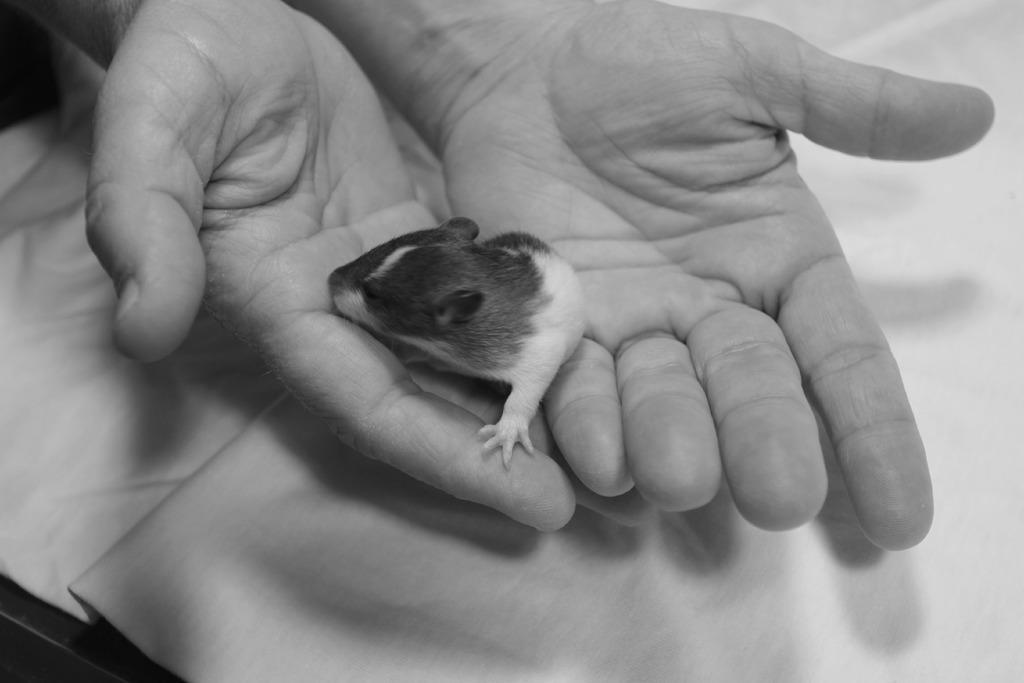In one or two sentences, can you explain what this image depicts? In this image there is a rat in the hand of the person. 